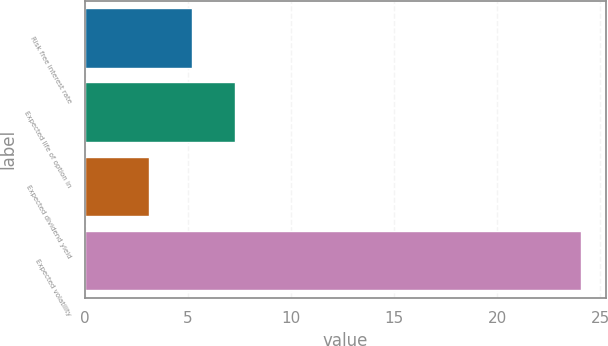Convert chart. <chart><loc_0><loc_0><loc_500><loc_500><bar_chart><fcel>Risk free interest rate<fcel>Expected life of option in<fcel>Expected dividend yield<fcel>Expected volatility<nl><fcel>5.2<fcel>7.3<fcel>3.1<fcel>24.1<nl></chart> 